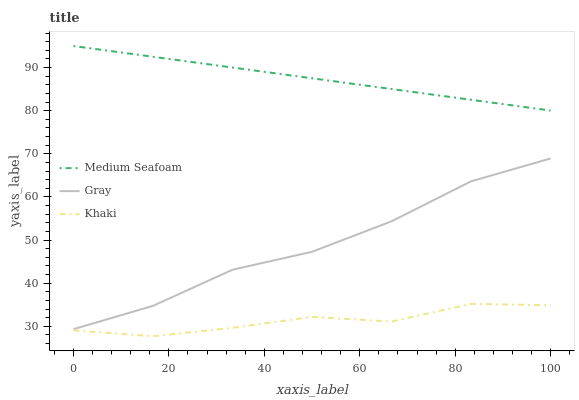Does Khaki have the minimum area under the curve?
Answer yes or no. Yes. Does Medium Seafoam have the maximum area under the curve?
Answer yes or no. Yes. Does Medium Seafoam have the minimum area under the curve?
Answer yes or no. No. Does Khaki have the maximum area under the curve?
Answer yes or no. No. Is Medium Seafoam the smoothest?
Answer yes or no. Yes. Is Khaki the roughest?
Answer yes or no. Yes. Is Khaki the smoothest?
Answer yes or no. No. Is Medium Seafoam the roughest?
Answer yes or no. No. Does Khaki have the lowest value?
Answer yes or no. Yes. Does Medium Seafoam have the lowest value?
Answer yes or no. No. Does Medium Seafoam have the highest value?
Answer yes or no. Yes. Does Khaki have the highest value?
Answer yes or no. No. Is Khaki less than Gray?
Answer yes or no. Yes. Is Medium Seafoam greater than Khaki?
Answer yes or no. Yes. Does Khaki intersect Gray?
Answer yes or no. No. 